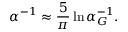<formula> <loc_0><loc_0><loc_500><loc_500>\alpha ^ { - 1 } \approx { \frac { 5 } { \pi } } \ln { \alpha _ { G } ^ { - 1 } } .</formula> 